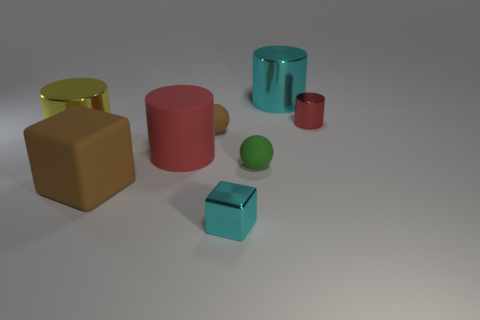Subtract all large cylinders. How many cylinders are left? 1 Subtract 0 green cubes. How many objects are left? 8 Subtract all cubes. How many objects are left? 6 Subtract 4 cylinders. How many cylinders are left? 0 Subtract all purple cylinders. Subtract all cyan blocks. How many cylinders are left? 4 Subtract all cyan blocks. How many brown balls are left? 1 Subtract all big brown rubber blocks. Subtract all brown balls. How many objects are left? 6 Add 1 small cubes. How many small cubes are left? 2 Add 5 tiny red cylinders. How many tiny red cylinders exist? 6 Add 2 small blue cylinders. How many objects exist? 10 